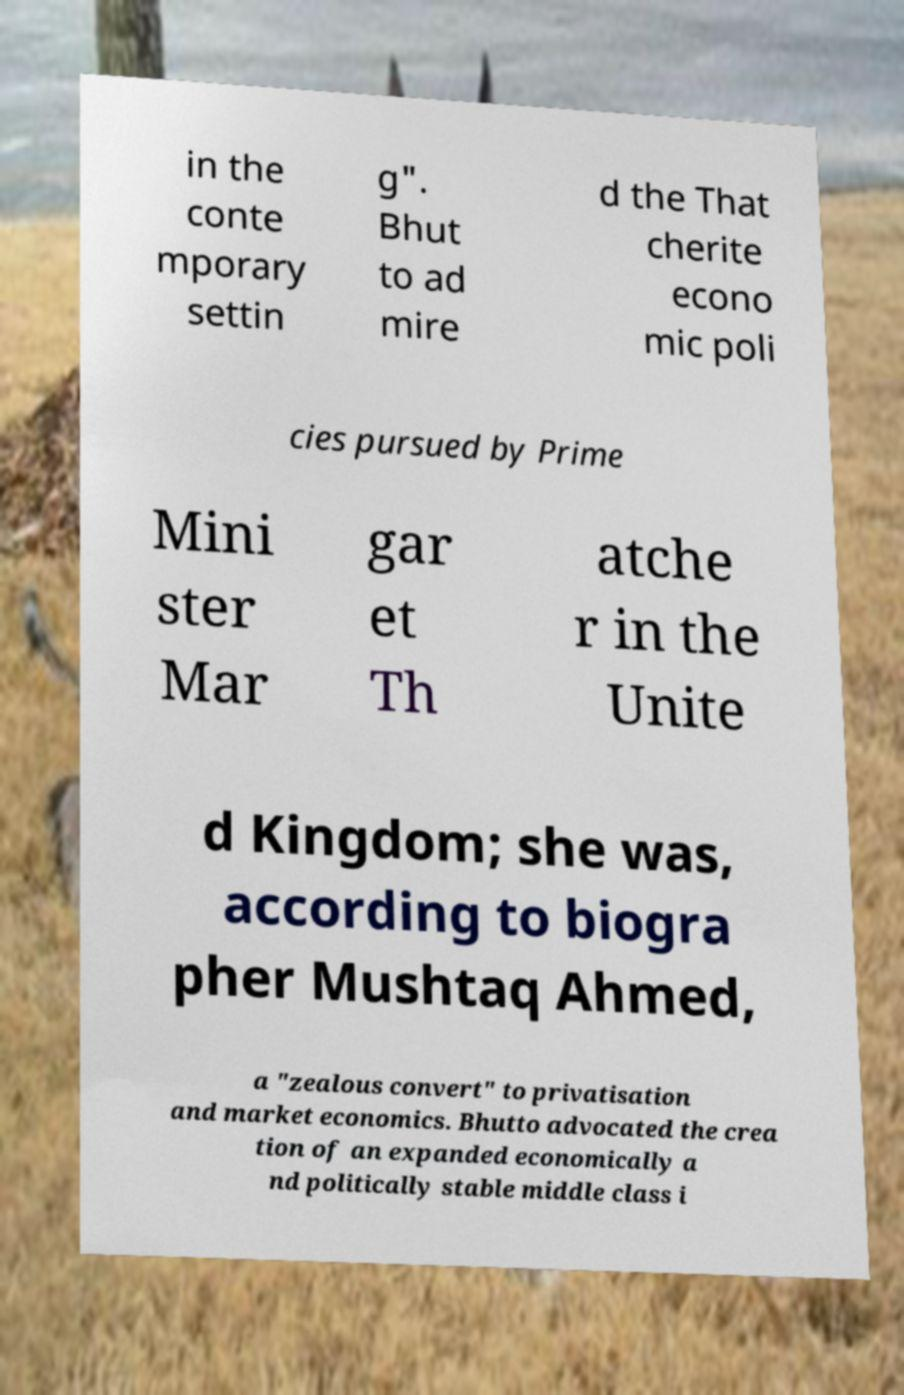Please read and relay the text visible in this image. What does it say? in the conte mporary settin g". Bhut to ad mire d the That cherite econo mic poli cies pursued by Prime Mini ster Mar gar et Th atche r in the Unite d Kingdom; she was, according to biogra pher Mushtaq Ahmed, a "zealous convert" to privatisation and market economics. Bhutto advocated the crea tion of an expanded economically a nd politically stable middle class i 